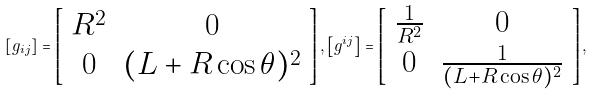Convert formula to latex. <formula><loc_0><loc_0><loc_500><loc_500>\left [ g _ { i j } \right ] = \left [ \begin{array} { c c } R ^ { 2 } & 0 \\ 0 & ( L + R \cos \theta ) ^ { 2 } \end{array} \right ] , \left [ g ^ { i j } \right ] = \left [ \begin{array} { c c } \frac { 1 } { R ^ { 2 } } & 0 \\ 0 & \frac { 1 } { ( L + R \cos \theta ) ^ { 2 } } \end{array} \right ] ,</formula> 